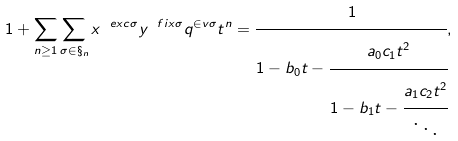Convert formula to latex. <formula><loc_0><loc_0><loc_500><loc_500>1 + \sum _ { n \geq 1 } \sum _ { \sigma \in \S _ { n } } x ^ { \ e x c \sigma } y ^ { \ f i x \sigma } q ^ { \in v \sigma } t ^ { n } = \cfrac { 1 } { 1 - b _ { 0 } t - \cfrac { a _ { 0 } c _ { 1 } t ^ { 2 } } { 1 - b _ { 1 } t - \cfrac { a _ { 1 } c _ { 2 } t ^ { 2 } } { \ddots } } } ,</formula> 